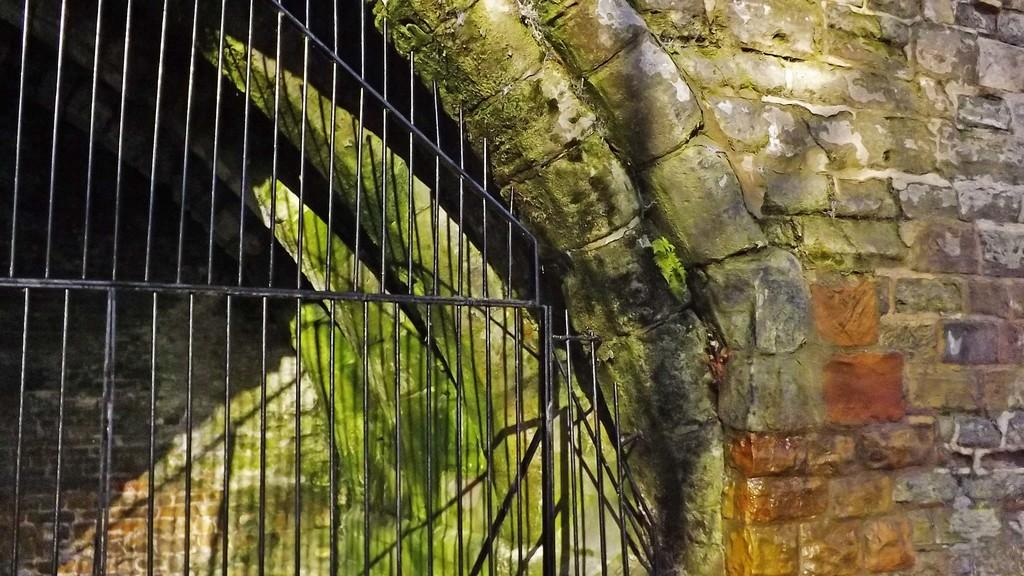What type of structure is located on the left side of the image? There is a cellar on the left side of the image. What can be seen on the right side of the image? There is a brick wall on the right side of the image. What type of flesh can be seen hanging from the brick wall in the image? There is no flesh present in the image; it features a cellar and a brick wall. How many ants are visible crawling on the cellar in the image? There are no ants visible in the image; it only shows a cellar and a brick wall. 